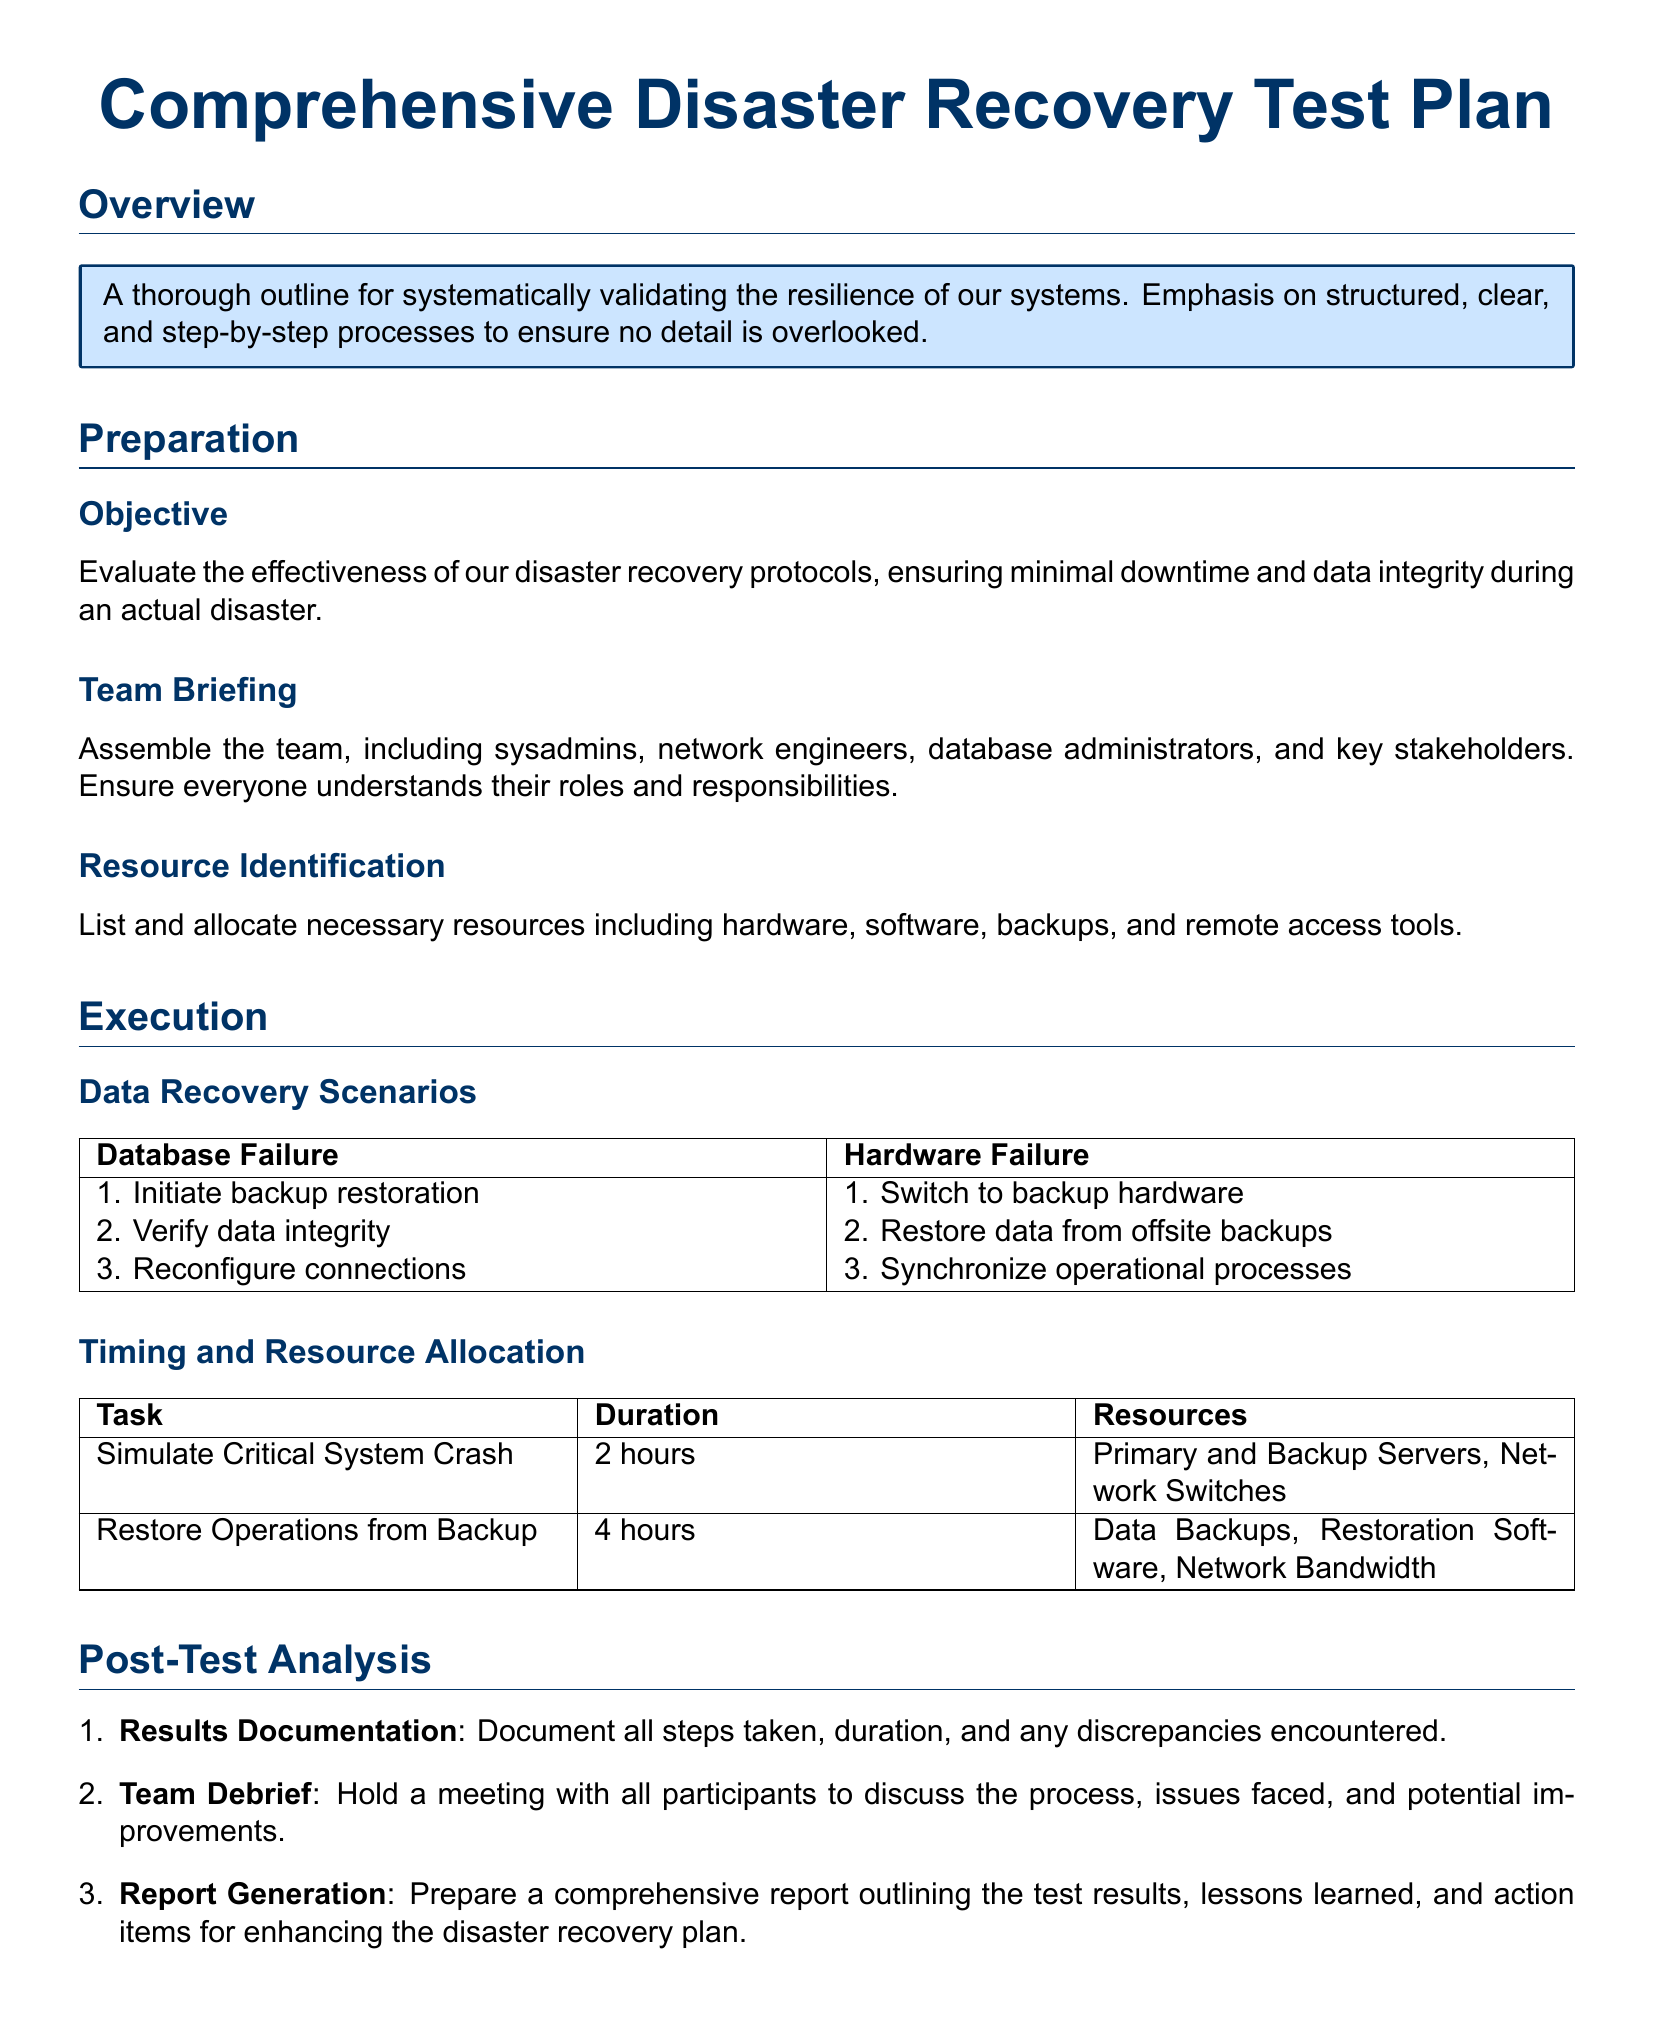What is the main objective of the disaster recovery test plan? The objective is to evaluate the effectiveness of disaster recovery protocols, ensuring minimal downtime and data integrity during an actual disaster.
Answer: Evaluate the effectiveness of our disaster recovery protocols Who should be included in the team briefing? The team should include sysadmins, network engineers, database administrators, and key stakeholders.
Answer: sysadmins, network engineers, database administrators, key stakeholders How long is the simulation of the critical system crash? The duration for simulating a critical system crash is specified in the document.
Answer: 2 hours What is the first step in the database failure scenario? The document outlines specific steps for scenarios; the first step for database failure is mentioned.
Answer: Initiate backup restoration What should be documented during the post-test analysis? The results documentation involves specific elements that need to be recorded.
Answer: All steps taken, duration, and any discrepancies encountered What is the total duration for restoring operations from backup? The duration for restoring operations from backup is indicated in the relevant section of the document.
Answer: 4 hours What follow-up action occurs after the team debrief? The document specifies actions to be taken post-team debrief, focusing on reporting.
Answer: Prepare a comprehensive report How many data recovery scenarios are listed in the document? The document includes a list of data recovery scenarios; counting them will reveal the number.
Answer: 2 scenarios What color is used for the headings in the document? The color formatting for sections is explicitly mentioned in the document details.
Answer: Main color (RGB 0, 51, 102) 